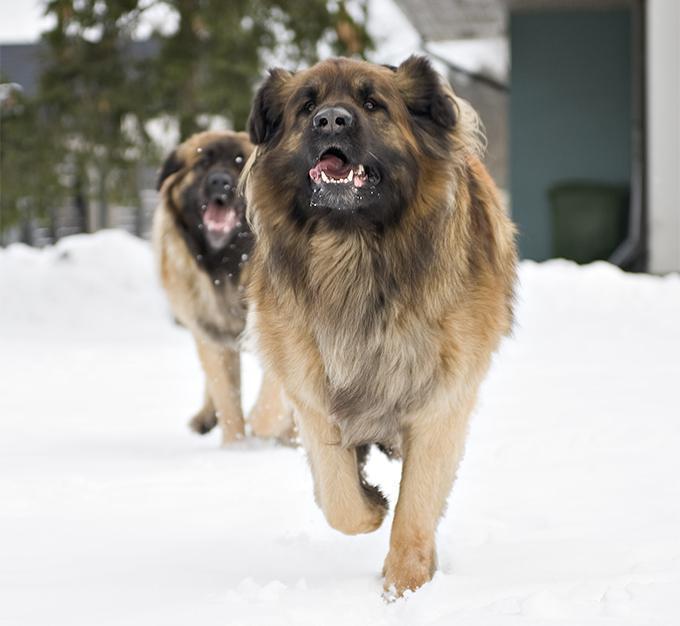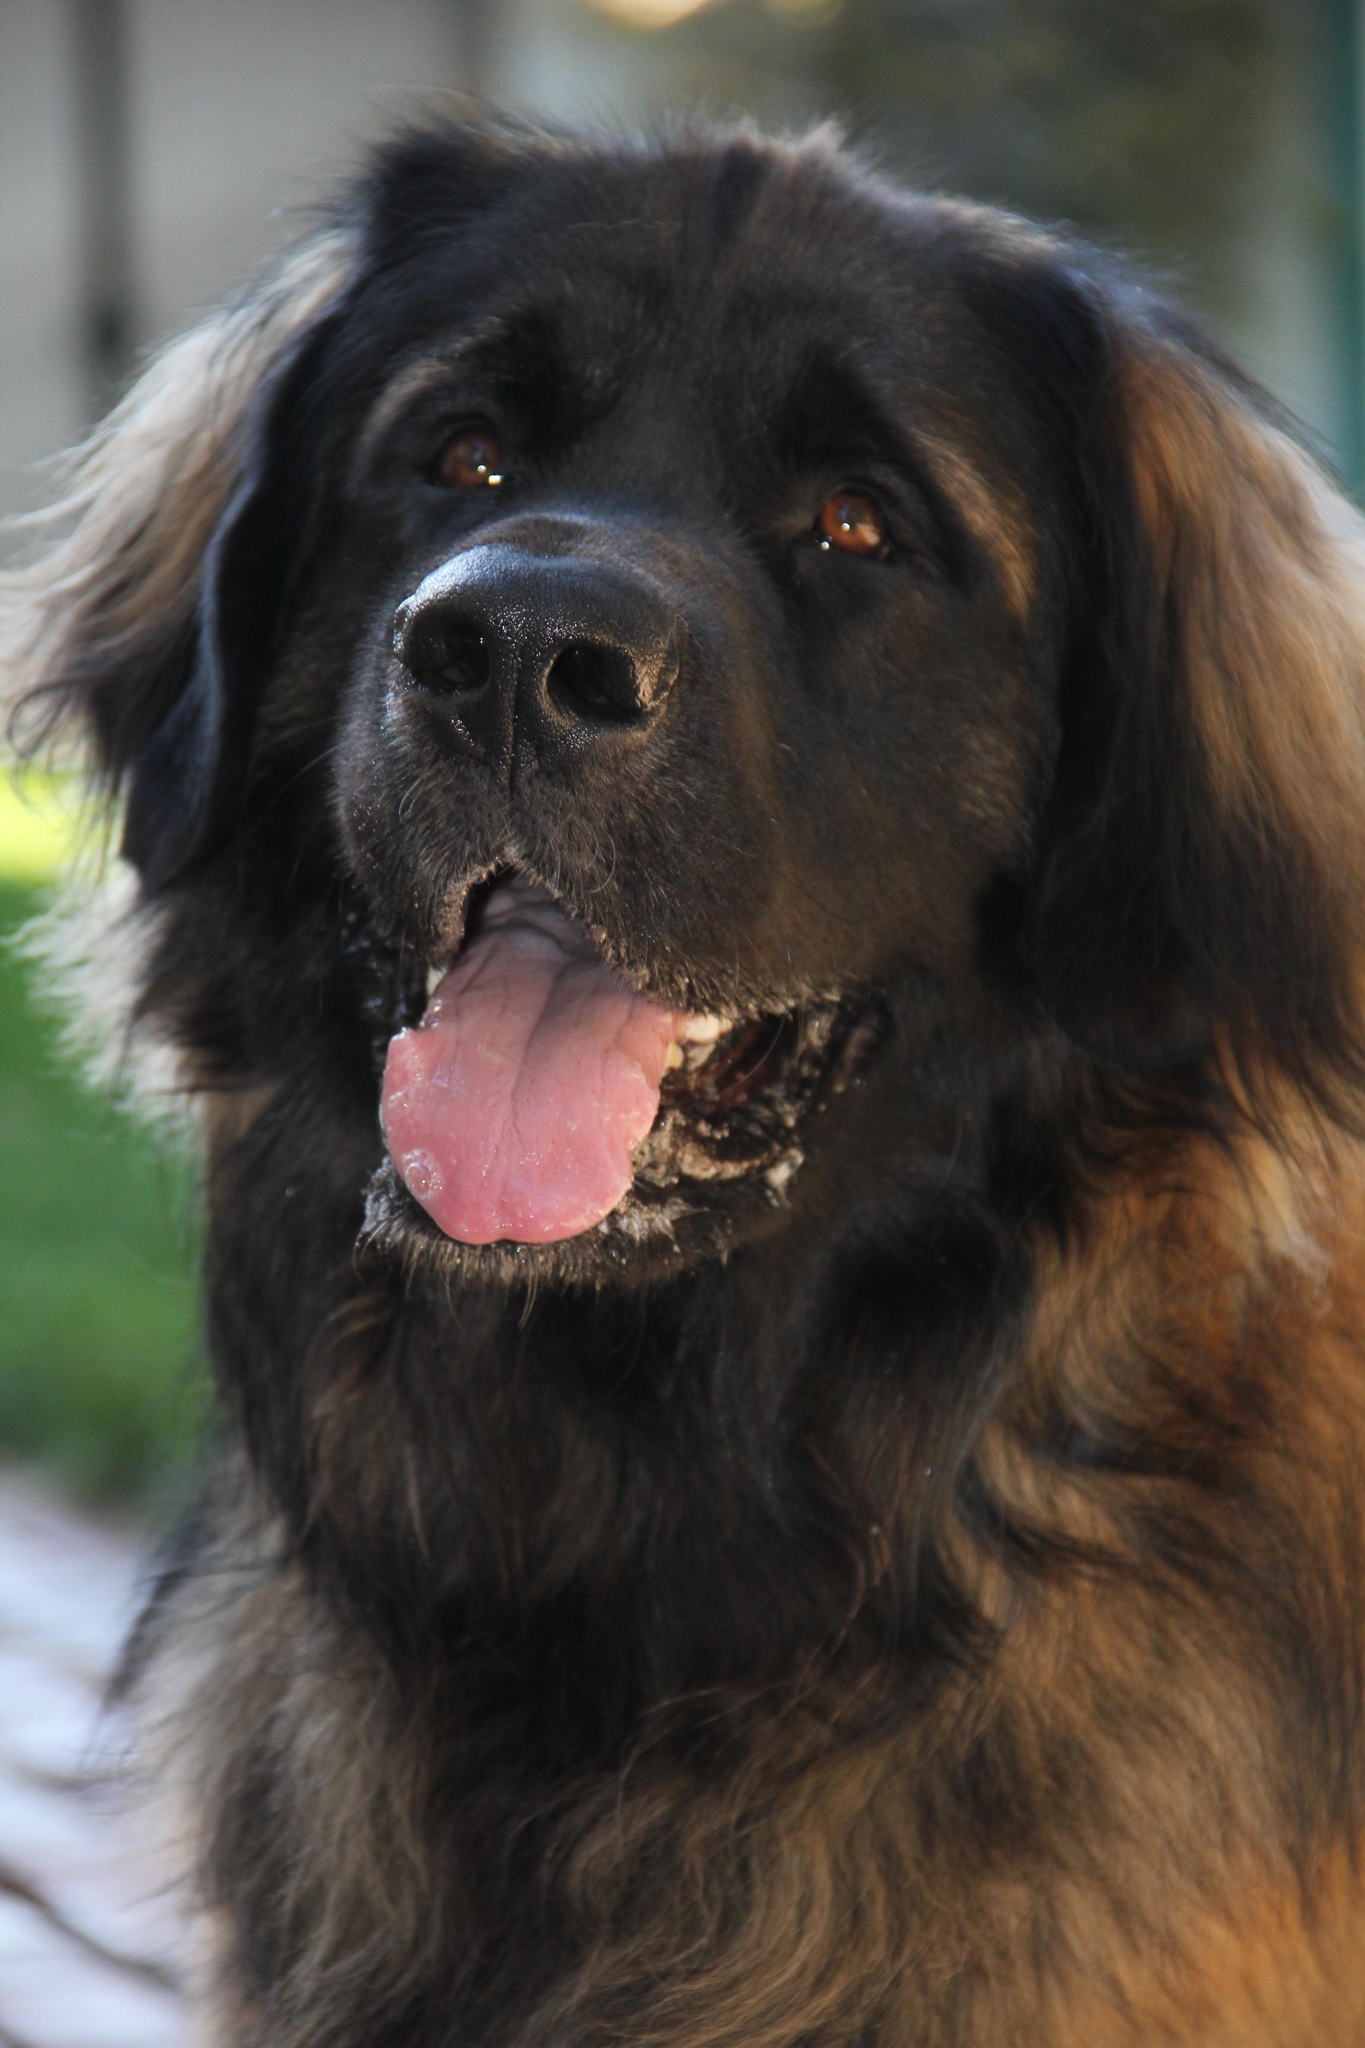The first image is the image on the left, the second image is the image on the right. Given the left and right images, does the statement "There is more than one dog in one of the images." hold true? Answer yes or no. Yes. 